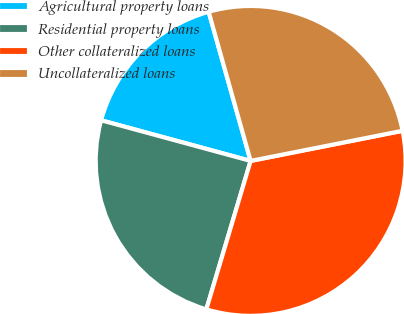Convert chart. <chart><loc_0><loc_0><loc_500><loc_500><pie_chart><fcel>Agricultural property loans<fcel>Residential property loans<fcel>Other collateralized loans<fcel>Uncollateralized loans<nl><fcel>16.41%<fcel>24.61%<fcel>32.73%<fcel>26.25%<nl></chart> 